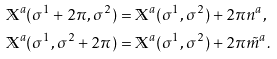Convert formula to latex. <formula><loc_0><loc_0><loc_500><loc_500>& \mathbb { X } ^ { a } ( \sigma ^ { 1 } + 2 \pi , \sigma ^ { 2 } ) = \mathbb { X } ^ { a } ( \sigma ^ { 1 } , \sigma ^ { 2 } ) + 2 \pi n ^ { a } , \\ & \mathbb { X } ^ { a } ( \sigma ^ { 1 } , \sigma ^ { 2 } + 2 \pi ) = \mathbb { X } ^ { a } ( \sigma ^ { 1 } , \sigma ^ { 2 } ) + 2 \pi \tilde { m } ^ { a } .</formula> 